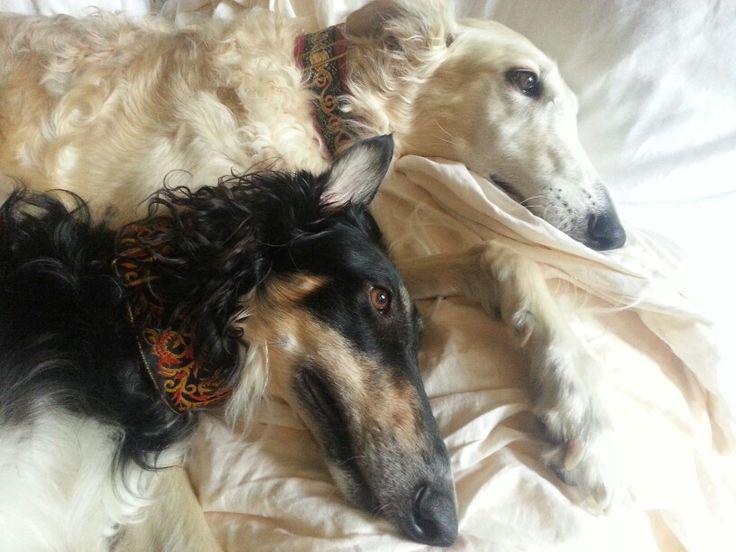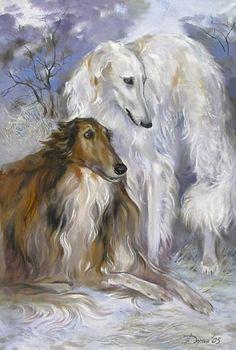The first image is the image on the left, the second image is the image on the right. Analyze the images presented: Is the assertion "The right image contains a painting with two dogs." valid? Answer yes or no. Yes. The first image is the image on the left, the second image is the image on the right. For the images displayed, is the sentence "In one image there is a lone Russian Wolfhound standing with its nose pointing to the left of the image." factually correct? Answer yes or no. No. 